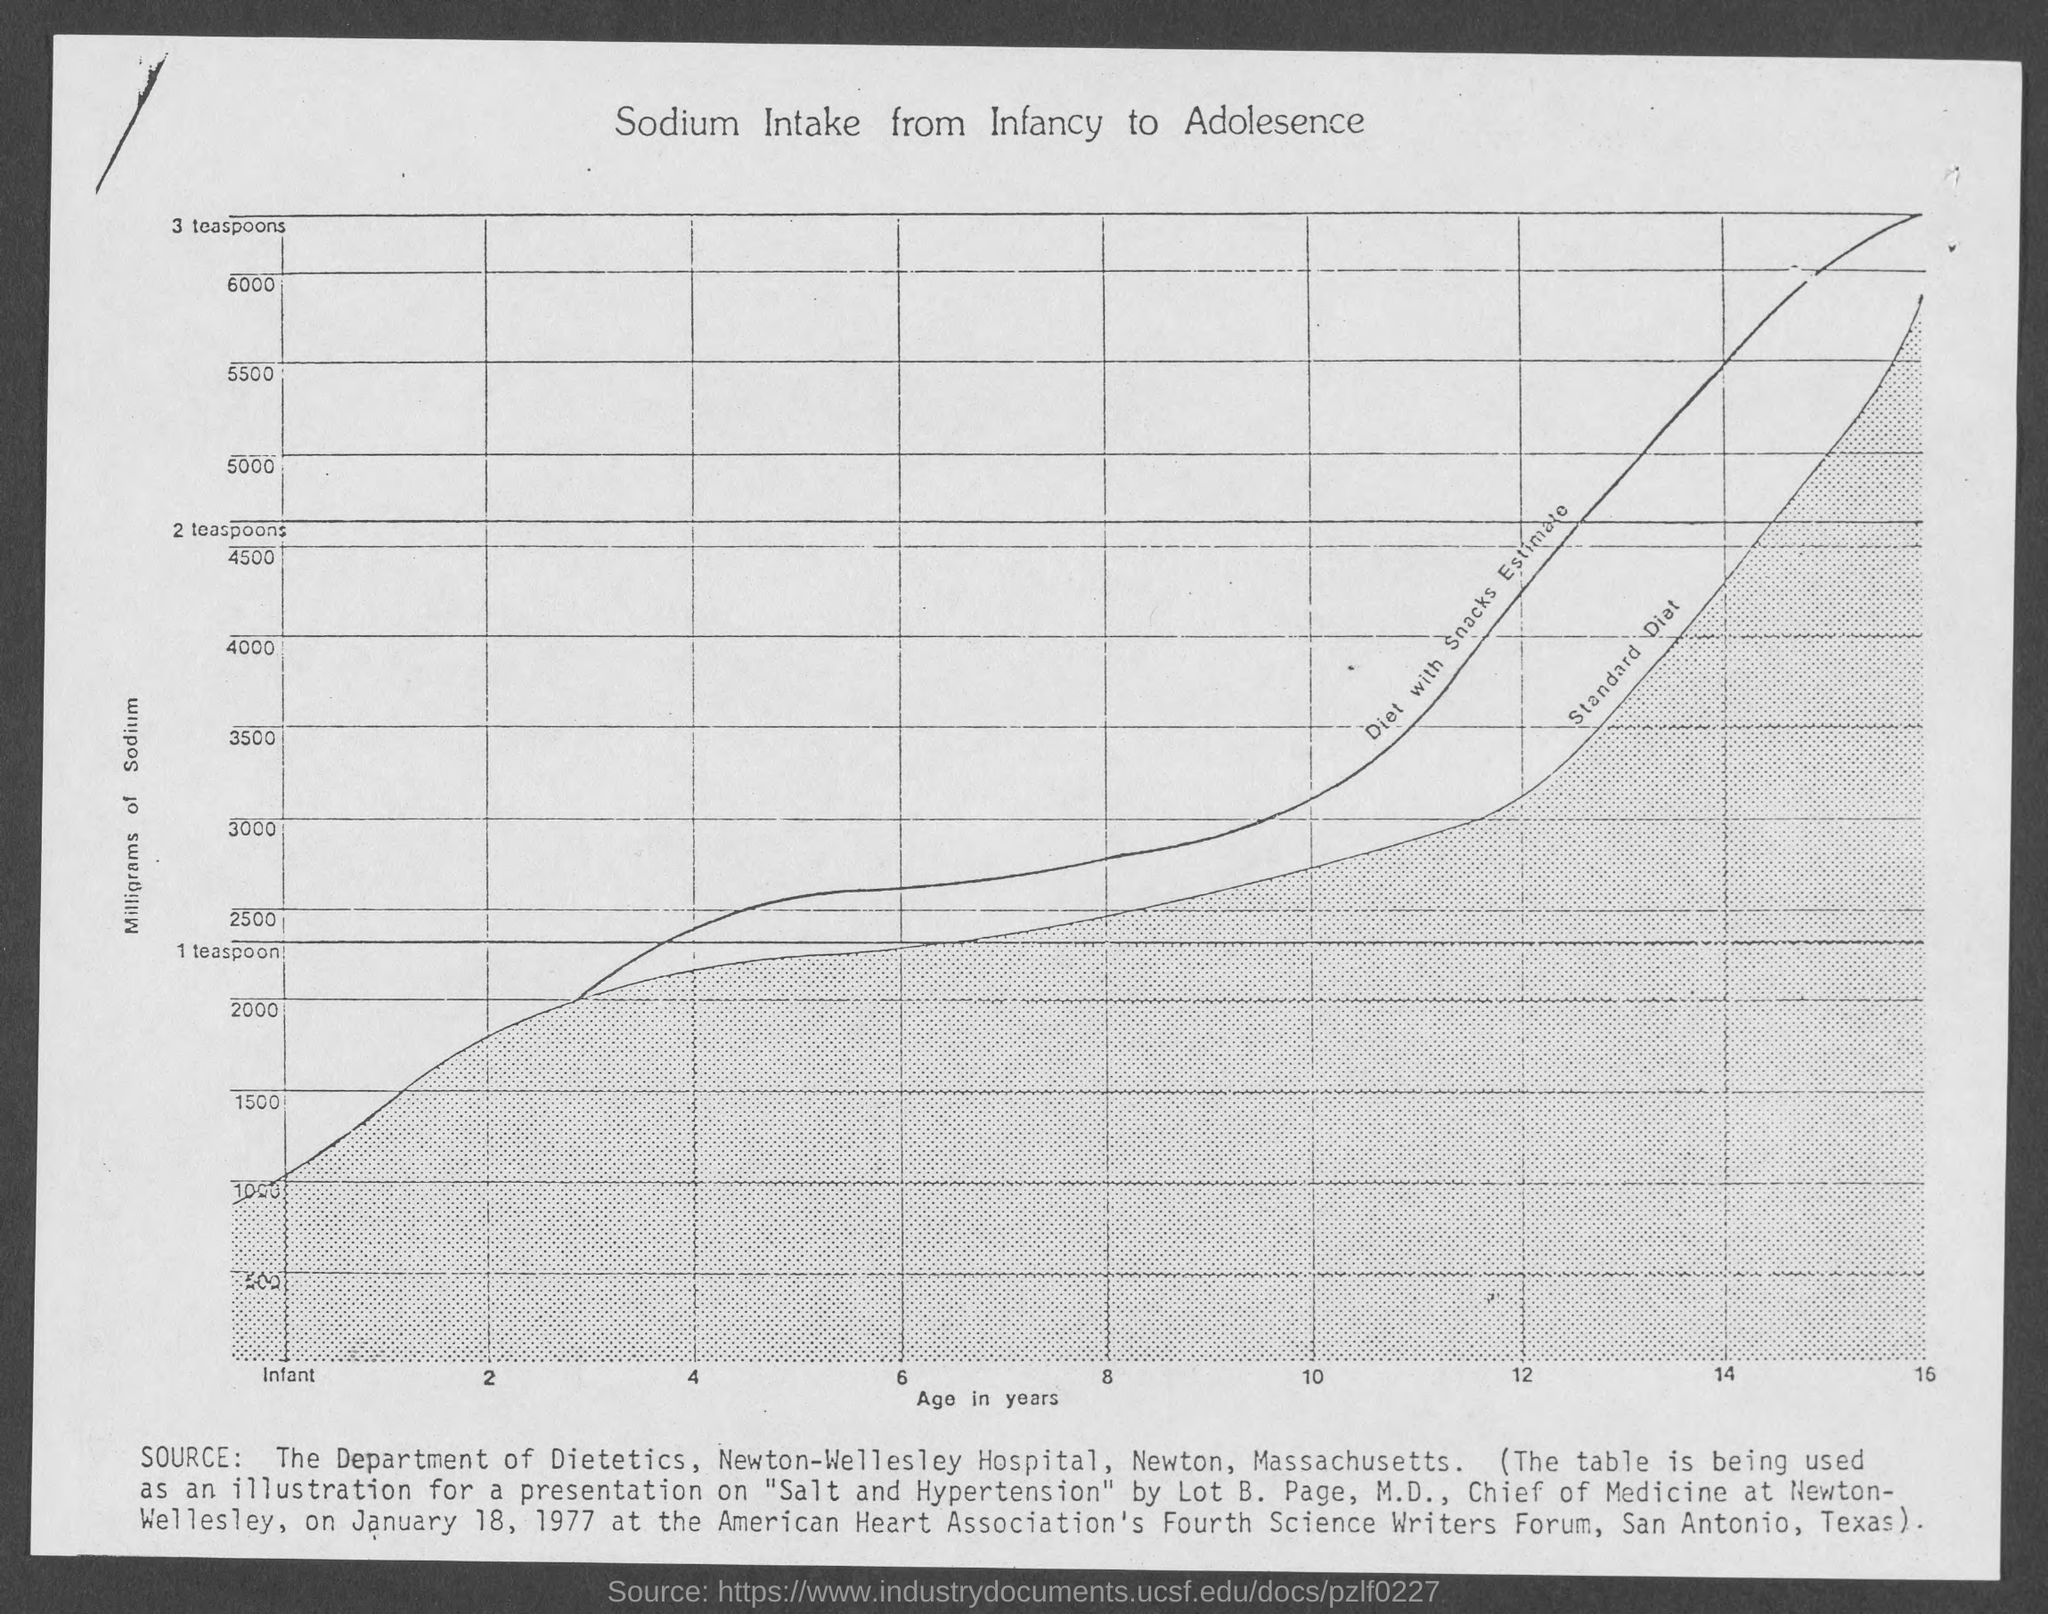List a handful of essential elements in this visual. The title of the graph is 'Sodium intake from infancy to adolescence.' 